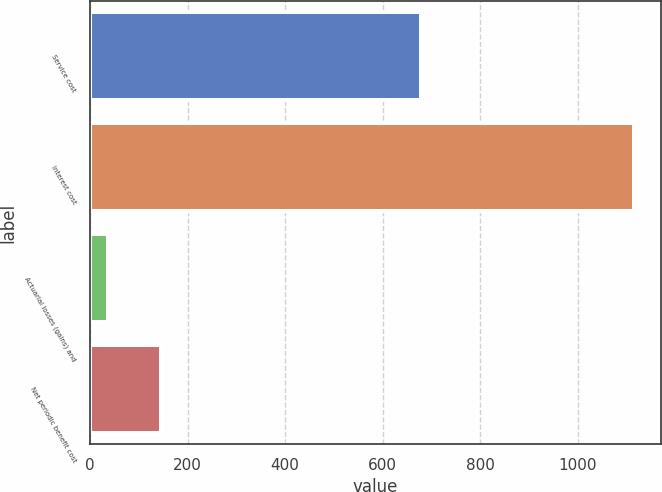Convert chart. <chart><loc_0><loc_0><loc_500><loc_500><bar_chart><fcel>Service cost<fcel>Interest cost<fcel>Actuarial losses (gains) and<fcel>Net periodic benefit cost<nl><fcel>679<fcel>1115<fcel>37<fcel>144.8<nl></chart> 